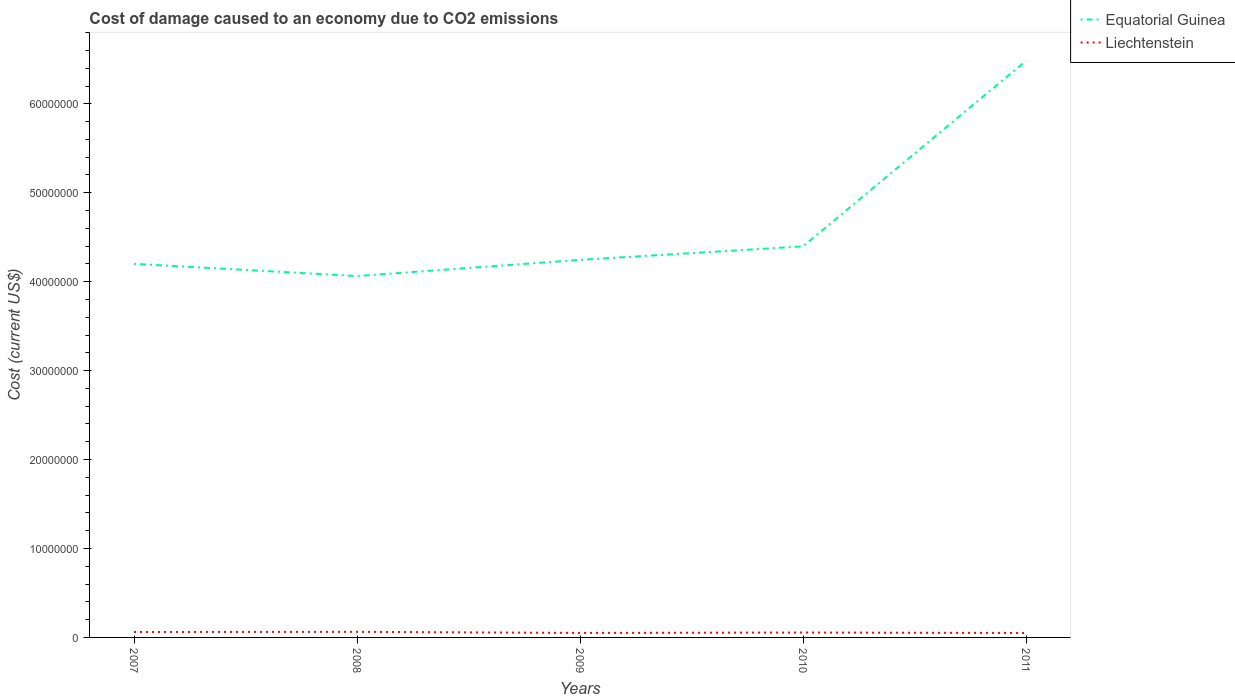How many different coloured lines are there?
Ensure brevity in your answer.  2. Does the line corresponding to Liechtenstein intersect with the line corresponding to Equatorial Guinea?
Offer a terse response. No. Is the number of lines equal to the number of legend labels?
Give a very brief answer. Yes. Across all years, what is the maximum cost of damage caused due to CO2 emissisons in Equatorial Guinea?
Offer a terse response. 4.06e+07. What is the total cost of damage caused due to CO2 emissisons in Liechtenstein in the graph?
Offer a very short reply. 1.13e+05. What is the difference between the highest and the second highest cost of damage caused due to CO2 emissisons in Liechtenstein?
Keep it short and to the point. 1.31e+05. What is the difference between the highest and the lowest cost of damage caused due to CO2 emissisons in Equatorial Guinea?
Give a very brief answer. 1. How many lines are there?
Keep it short and to the point. 2. How many years are there in the graph?
Give a very brief answer. 5. What is the difference between two consecutive major ticks on the Y-axis?
Keep it short and to the point. 1.00e+07. Does the graph contain grids?
Provide a succinct answer. No. How are the legend labels stacked?
Provide a succinct answer. Vertical. What is the title of the graph?
Provide a short and direct response. Cost of damage caused to an economy due to CO2 emissions. What is the label or title of the X-axis?
Provide a short and direct response. Years. What is the label or title of the Y-axis?
Keep it short and to the point. Cost (current US$). What is the Cost (current US$) of Equatorial Guinea in 2007?
Ensure brevity in your answer.  4.20e+07. What is the Cost (current US$) in Liechtenstein in 2007?
Your response must be concise. 6.10e+05. What is the Cost (current US$) in Equatorial Guinea in 2008?
Your response must be concise. 4.06e+07. What is the Cost (current US$) in Liechtenstein in 2008?
Provide a succinct answer. 6.29e+05. What is the Cost (current US$) in Equatorial Guinea in 2009?
Your response must be concise. 4.25e+07. What is the Cost (current US$) of Liechtenstein in 2009?
Make the answer very short. 5.05e+05. What is the Cost (current US$) in Equatorial Guinea in 2010?
Give a very brief answer. 4.40e+07. What is the Cost (current US$) of Liechtenstein in 2010?
Your answer should be very brief. 5.51e+05. What is the Cost (current US$) of Equatorial Guinea in 2011?
Provide a succinct answer. 6.48e+07. What is the Cost (current US$) in Liechtenstein in 2011?
Provide a succinct answer. 4.98e+05. Across all years, what is the maximum Cost (current US$) of Equatorial Guinea?
Ensure brevity in your answer.  6.48e+07. Across all years, what is the maximum Cost (current US$) of Liechtenstein?
Offer a very short reply. 6.29e+05. Across all years, what is the minimum Cost (current US$) of Equatorial Guinea?
Your answer should be very brief. 4.06e+07. Across all years, what is the minimum Cost (current US$) of Liechtenstein?
Keep it short and to the point. 4.98e+05. What is the total Cost (current US$) of Equatorial Guinea in the graph?
Offer a very short reply. 2.34e+08. What is the total Cost (current US$) in Liechtenstein in the graph?
Your response must be concise. 2.79e+06. What is the difference between the Cost (current US$) of Equatorial Guinea in 2007 and that in 2008?
Provide a short and direct response. 1.37e+06. What is the difference between the Cost (current US$) in Liechtenstein in 2007 and that in 2008?
Offer a very short reply. -1.85e+04. What is the difference between the Cost (current US$) in Equatorial Guinea in 2007 and that in 2009?
Provide a succinct answer. -4.44e+05. What is the difference between the Cost (current US$) in Liechtenstein in 2007 and that in 2009?
Offer a terse response. 1.05e+05. What is the difference between the Cost (current US$) in Equatorial Guinea in 2007 and that in 2010?
Your answer should be compact. -1.97e+06. What is the difference between the Cost (current US$) of Liechtenstein in 2007 and that in 2010?
Ensure brevity in your answer.  5.88e+04. What is the difference between the Cost (current US$) in Equatorial Guinea in 2007 and that in 2011?
Make the answer very short. -2.28e+07. What is the difference between the Cost (current US$) in Liechtenstein in 2007 and that in 2011?
Your answer should be very brief. 1.13e+05. What is the difference between the Cost (current US$) of Equatorial Guinea in 2008 and that in 2009?
Give a very brief answer. -1.82e+06. What is the difference between the Cost (current US$) of Liechtenstein in 2008 and that in 2009?
Provide a succinct answer. 1.23e+05. What is the difference between the Cost (current US$) of Equatorial Guinea in 2008 and that in 2010?
Your answer should be very brief. -3.34e+06. What is the difference between the Cost (current US$) in Liechtenstein in 2008 and that in 2010?
Offer a terse response. 7.73e+04. What is the difference between the Cost (current US$) in Equatorial Guinea in 2008 and that in 2011?
Offer a very short reply. -2.42e+07. What is the difference between the Cost (current US$) of Liechtenstein in 2008 and that in 2011?
Your response must be concise. 1.31e+05. What is the difference between the Cost (current US$) of Equatorial Guinea in 2009 and that in 2010?
Your answer should be compact. -1.52e+06. What is the difference between the Cost (current US$) of Liechtenstein in 2009 and that in 2010?
Make the answer very short. -4.60e+04. What is the difference between the Cost (current US$) of Equatorial Guinea in 2009 and that in 2011?
Offer a very short reply. -2.24e+07. What is the difference between the Cost (current US$) of Liechtenstein in 2009 and that in 2011?
Provide a succinct answer. 7772.56. What is the difference between the Cost (current US$) in Equatorial Guinea in 2010 and that in 2011?
Provide a succinct answer. -2.09e+07. What is the difference between the Cost (current US$) in Liechtenstein in 2010 and that in 2011?
Provide a short and direct response. 5.38e+04. What is the difference between the Cost (current US$) of Equatorial Guinea in 2007 and the Cost (current US$) of Liechtenstein in 2008?
Ensure brevity in your answer.  4.14e+07. What is the difference between the Cost (current US$) of Equatorial Guinea in 2007 and the Cost (current US$) of Liechtenstein in 2009?
Give a very brief answer. 4.15e+07. What is the difference between the Cost (current US$) in Equatorial Guinea in 2007 and the Cost (current US$) in Liechtenstein in 2010?
Your answer should be compact. 4.15e+07. What is the difference between the Cost (current US$) in Equatorial Guinea in 2007 and the Cost (current US$) in Liechtenstein in 2011?
Your answer should be very brief. 4.15e+07. What is the difference between the Cost (current US$) in Equatorial Guinea in 2008 and the Cost (current US$) in Liechtenstein in 2009?
Provide a succinct answer. 4.01e+07. What is the difference between the Cost (current US$) in Equatorial Guinea in 2008 and the Cost (current US$) in Liechtenstein in 2010?
Offer a terse response. 4.01e+07. What is the difference between the Cost (current US$) in Equatorial Guinea in 2008 and the Cost (current US$) in Liechtenstein in 2011?
Ensure brevity in your answer.  4.01e+07. What is the difference between the Cost (current US$) in Equatorial Guinea in 2009 and the Cost (current US$) in Liechtenstein in 2010?
Your response must be concise. 4.19e+07. What is the difference between the Cost (current US$) in Equatorial Guinea in 2009 and the Cost (current US$) in Liechtenstein in 2011?
Your response must be concise. 4.20e+07. What is the difference between the Cost (current US$) of Equatorial Guinea in 2010 and the Cost (current US$) of Liechtenstein in 2011?
Your answer should be very brief. 4.35e+07. What is the average Cost (current US$) in Equatorial Guinea per year?
Your answer should be compact. 4.68e+07. What is the average Cost (current US$) in Liechtenstein per year?
Offer a very short reply. 5.59e+05. In the year 2007, what is the difference between the Cost (current US$) of Equatorial Guinea and Cost (current US$) of Liechtenstein?
Your response must be concise. 4.14e+07. In the year 2008, what is the difference between the Cost (current US$) in Equatorial Guinea and Cost (current US$) in Liechtenstein?
Your answer should be very brief. 4.00e+07. In the year 2009, what is the difference between the Cost (current US$) in Equatorial Guinea and Cost (current US$) in Liechtenstein?
Give a very brief answer. 4.19e+07. In the year 2010, what is the difference between the Cost (current US$) in Equatorial Guinea and Cost (current US$) in Liechtenstein?
Keep it short and to the point. 4.34e+07. In the year 2011, what is the difference between the Cost (current US$) in Equatorial Guinea and Cost (current US$) in Liechtenstein?
Your answer should be compact. 6.43e+07. What is the ratio of the Cost (current US$) of Equatorial Guinea in 2007 to that in 2008?
Ensure brevity in your answer.  1.03. What is the ratio of the Cost (current US$) in Liechtenstein in 2007 to that in 2008?
Provide a short and direct response. 0.97. What is the ratio of the Cost (current US$) in Liechtenstein in 2007 to that in 2009?
Your answer should be compact. 1.21. What is the ratio of the Cost (current US$) in Equatorial Guinea in 2007 to that in 2010?
Provide a succinct answer. 0.96. What is the ratio of the Cost (current US$) of Liechtenstein in 2007 to that in 2010?
Offer a terse response. 1.11. What is the ratio of the Cost (current US$) of Equatorial Guinea in 2007 to that in 2011?
Your response must be concise. 0.65. What is the ratio of the Cost (current US$) in Liechtenstein in 2007 to that in 2011?
Your response must be concise. 1.23. What is the ratio of the Cost (current US$) of Equatorial Guinea in 2008 to that in 2009?
Provide a short and direct response. 0.96. What is the ratio of the Cost (current US$) in Liechtenstein in 2008 to that in 2009?
Ensure brevity in your answer.  1.24. What is the ratio of the Cost (current US$) of Equatorial Guinea in 2008 to that in 2010?
Make the answer very short. 0.92. What is the ratio of the Cost (current US$) of Liechtenstein in 2008 to that in 2010?
Keep it short and to the point. 1.14. What is the ratio of the Cost (current US$) in Equatorial Guinea in 2008 to that in 2011?
Keep it short and to the point. 0.63. What is the ratio of the Cost (current US$) of Liechtenstein in 2008 to that in 2011?
Your answer should be very brief. 1.26. What is the ratio of the Cost (current US$) in Equatorial Guinea in 2009 to that in 2010?
Your answer should be compact. 0.97. What is the ratio of the Cost (current US$) in Liechtenstein in 2009 to that in 2010?
Keep it short and to the point. 0.92. What is the ratio of the Cost (current US$) in Equatorial Guinea in 2009 to that in 2011?
Provide a succinct answer. 0.65. What is the ratio of the Cost (current US$) of Liechtenstein in 2009 to that in 2011?
Give a very brief answer. 1.02. What is the ratio of the Cost (current US$) in Equatorial Guinea in 2010 to that in 2011?
Give a very brief answer. 0.68. What is the ratio of the Cost (current US$) of Liechtenstein in 2010 to that in 2011?
Provide a short and direct response. 1.11. What is the difference between the highest and the second highest Cost (current US$) in Equatorial Guinea?
Give a very brief answer. 2.09e+07. What is the difference between the highest and the second highest Cost (current US$) of Liechtenstein?
Offer a terse response. 1.85e+04. What is the difference between the highest and the lowest Cost (current US$) in Equatorial Guinea?
Ensure brevity in your answer.  2.42e+07. What is the difference between the highest and the lowest Cost (current US$) of Liechtenstein?
Keep it short and to the point. 1.31e+05. 